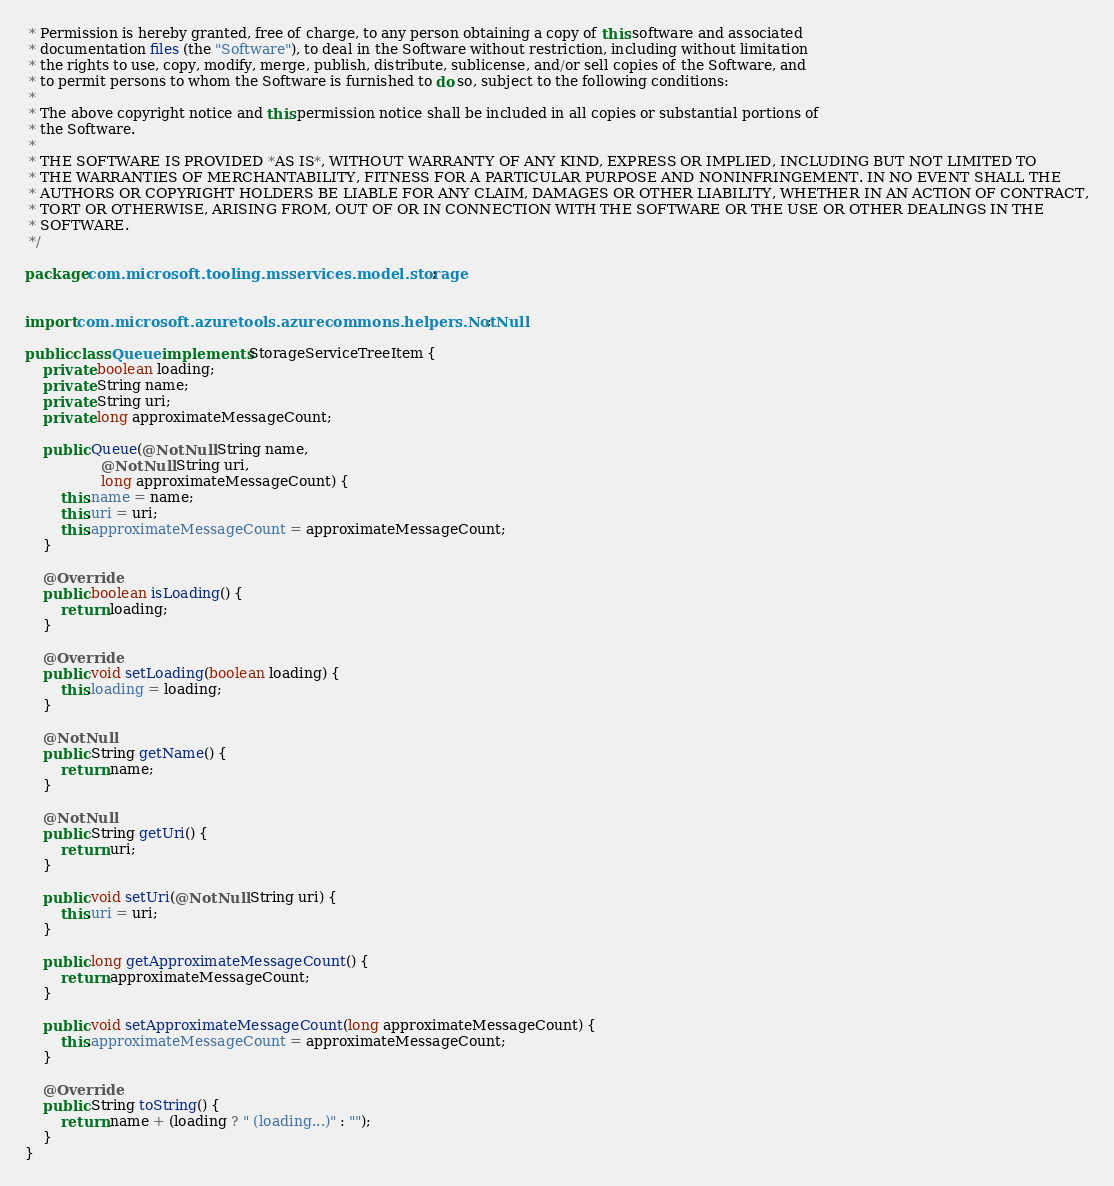<code> <loc_0><loc_0><loc_500><loc_500><_Java_> * Permission is hereby granted, free of charge, to any person obtaining a copy of this software and associated
 * documentation files (the "Software"), to deal in the Software without restriction, including without limitation
 * the rights to use, copy, modify, merge, publish, distribute, sublicense, and/or sell copies of the Software, and
 * to permit persons to whom the Software is furnished to do so, subject to the following conditions:
 *
 * The above copyright notice and this permission notice shall be included in all copies or substantial portions of
 * the Software.
 *
 * THE SOFTWARE IS PROVIDED *AS IS*, WITHOUT WARRANTY OF ANY KIND, EXPRESS OR IMPLIED, INCLUDING BUT NOT LIMITED TO
 * THE WARRANTIES OF MERCHANTABILITY, FITNESS FOR A PARTICULAR PURPOSE AND NONINFRINGEMENT. IN NO EVENT SHALL THE
 * AUTHORS OR COPYRIGHT HOLDERS BE LIABLE FOR ANY CLAIM, DAMAGES OR OTHER LIABILITY, WHETHER IN AN ACTION OF CONTRACT,
 * TORT OR OTHERWISE, ARISING FROM, OUT OF OR IN CONNECTION WITH THE SOFTWARE OR THE USE OR OTHER DEALINGS IN THE
 * SOFTWARE.
 */

package com.microsoft.tooling.msservices.model.storage;


import com.microsoft.azuretools.azurecommons.helpers.NotNull;

public class Queue implements StorageServiceTreeItem {
    private boolean loading;
    private String name;
    private String uri;
    private long approximateMessageCount;

    public Queue(@NotNull String name,
                 @NotNull String uri,
                 long approximateMessageCount) {
        this.name = name;
        this.uri = uri;
        this.approximateMessageCount = approximateMessageCount;
    }

    @Override
    public boolean isLoading() {
        return loading;
    }

    @Override
    public void setLoading(boolean loading) {
        this.loading = loading;
    }

    @NotNull
    public String getName() {
        return name;
    }

    @NotNull
    public String getUri() {
        return uri;
    }

    public void setUri(@NotNull String uri) {
        this.uri = uri;
    }

    public long getApproximateMessageCount() {
        return approximateMessageCount;
    }

    public void setApproximateMessageCount(long approximateMessageCount) {
        this.approximateMessageCount = approximateMessageCount;
    }

    @Override
    public String toString() {
        return name + (loading ? " (loading...)" : "");
    }
}
</code> 